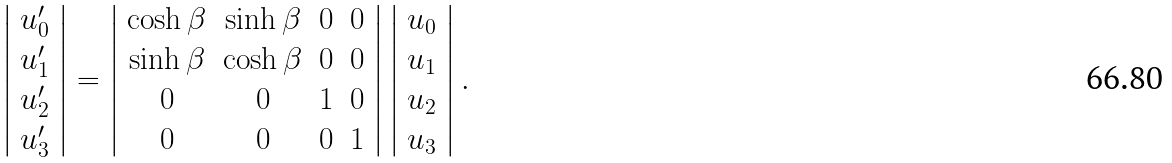<formula> <loc_0><loc_0><loc_500><loc_500>\left | \begin{array} { c } u ^ { \prime } _ { 0 } \\ u ^ { \prime } _ { 1 } \\ u ^ { \prime } _ { 2 } \\ u ^ { \prime } _ { 3 } \end{array} \right | = \left | \begin{array} { c c c c } \cosh \beta & \sinh \beta & 0 & 0 \\ \sinh \beta & \cosh \beta & 0 & 0 \\ 0 & 0 & 1 & 0 \\ 0 & 0 & 0 & 1 \end{array} \right | \left | \begin{array} { c } u _ { 0 } \\ u _ { 1 } \\ u _ { 2 } \\ u _ { 3 } \end{array} \right | .</formula> 